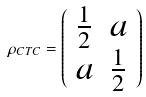Convert formula to latex. <formula><loc_0><loc_0><loc_500><loc_500>\rho _ { C T C } = { \left ( \begin{array} { l l } { { \frac { 1 } { 2 } } } & { a } \\ { a } & { { \frac { 1 } { 2 } } } \end{array} \right ) }</formula> 